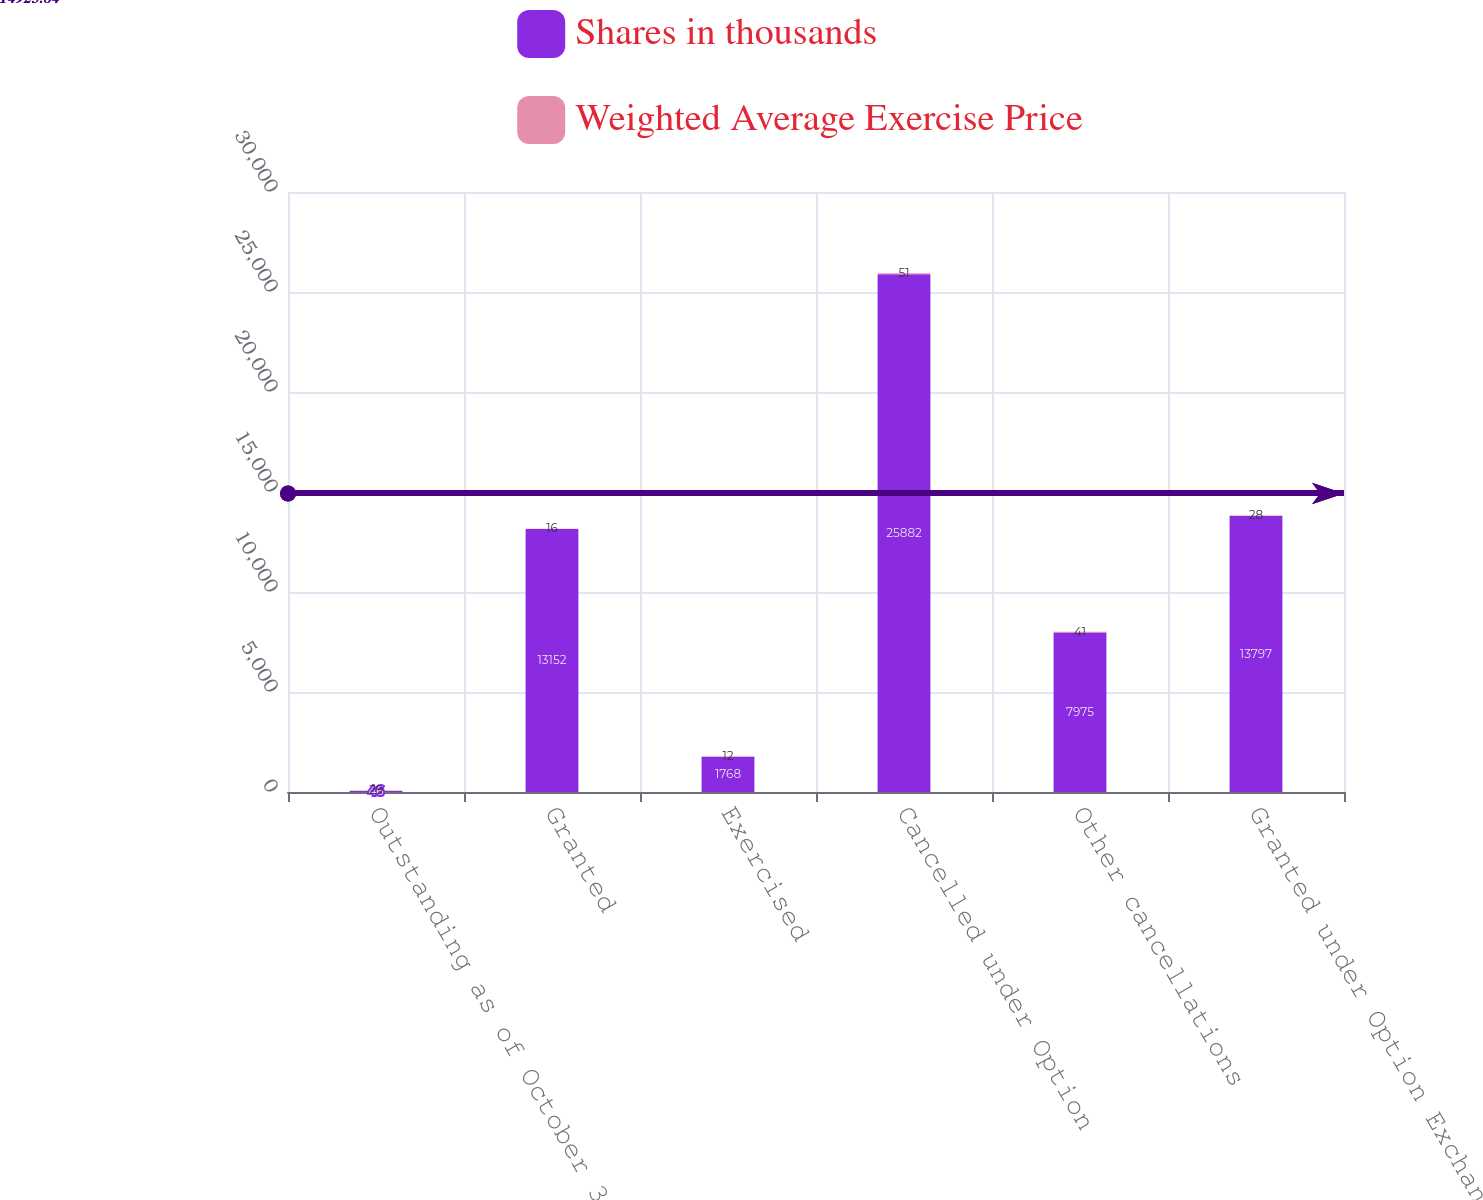<chart> <loc_0><loc_0><loc_500><loc_500><stacked_bar_chart><ecel><fcel>Outstanding as of October 31<fcel>Granted<fcel>Exercised<fcel>Cancelled under Option<fcel>Other cancellations<fcel>Granted under Option Exchange<nl><fcel>Shares in thousands<fcel>46<fcel>13152<fcel>1768<fcel>25882<fcel>7975<fcel>13797<nl><fcel>Weighted Average Exercise Price<fcel>29<fcel>16<fcel>12<fcel>51<fcel>41<fcel>28<nl></chart> 